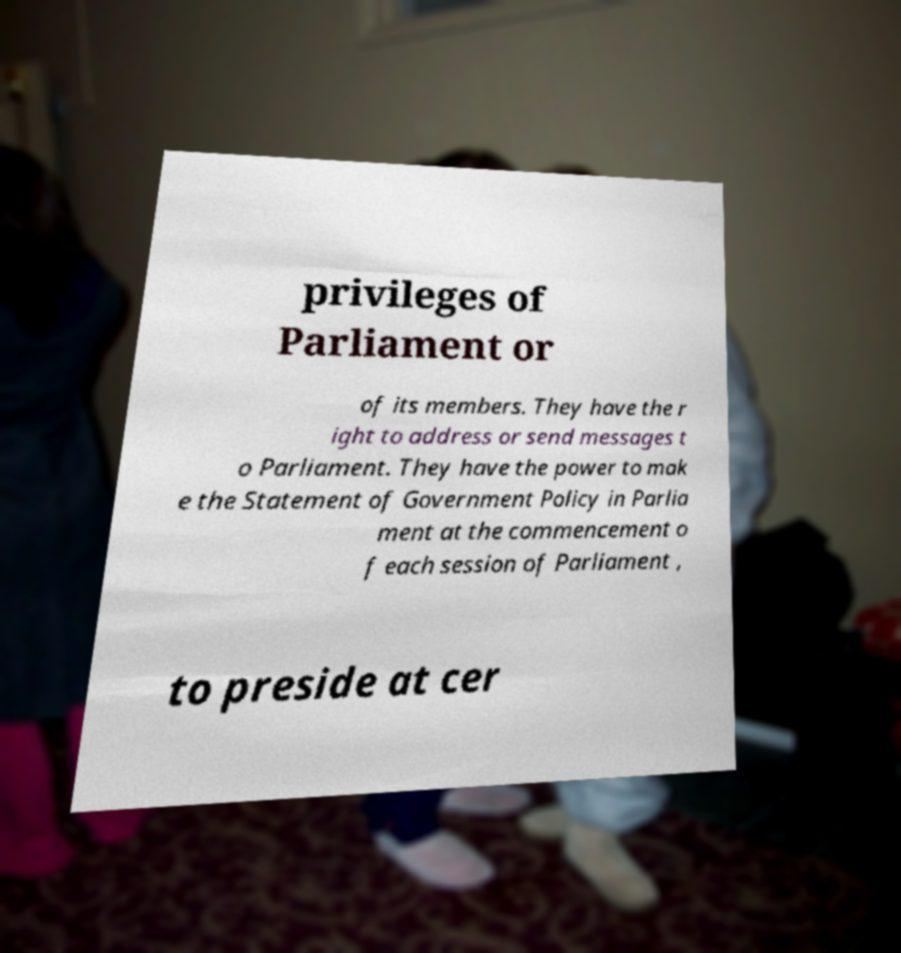Please identify and transcribe the text found in this image. privileges of Parliament or of its members. They have the r ight to address or send messages t o Parliament. They have the power to mak e the Statement of Government Policy in Parlia ment at the commencement o f each session of Parliament , to preside at cer 